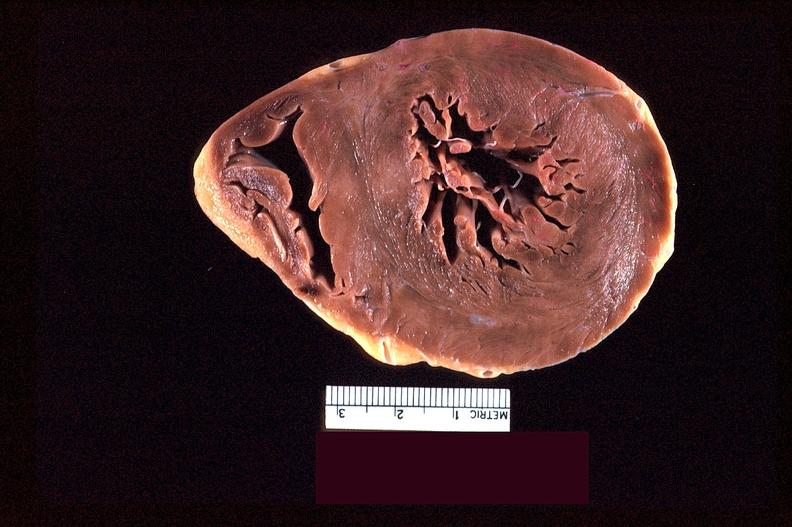what does this image show?
Answer the question using a single word or phrase. Heart slice 